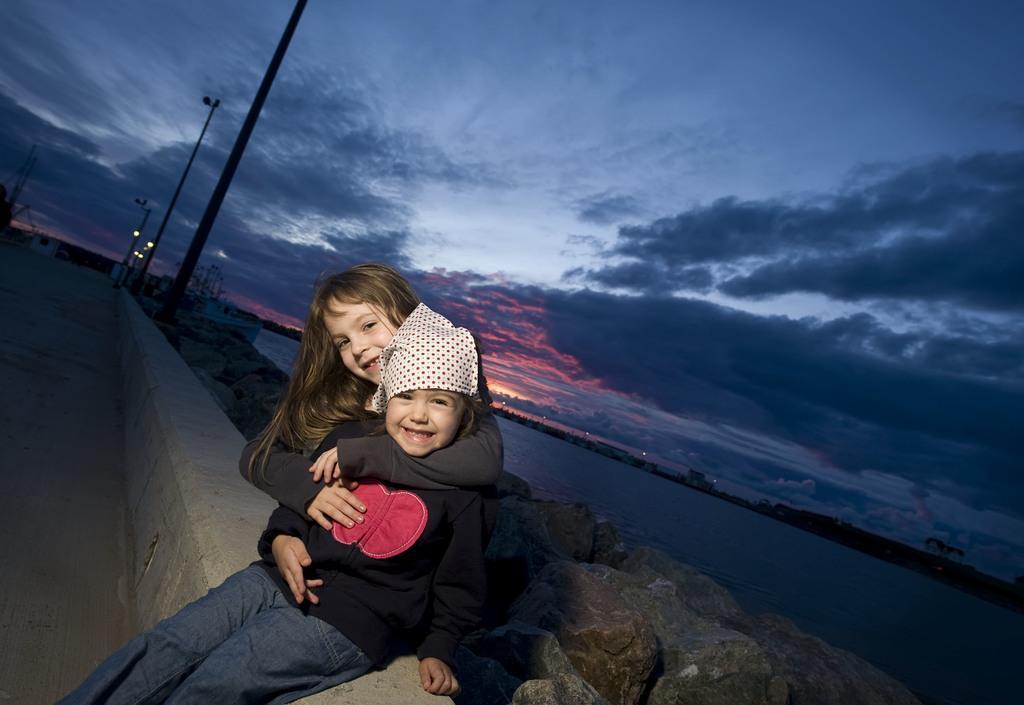Can you describe this image briefly? In this image I can see two persons. In front the person is wearing black jacket, blue pant and the other person is wearing black shirt. Background I can see few light poles, water, stones and the sky is in blue and gray color. 